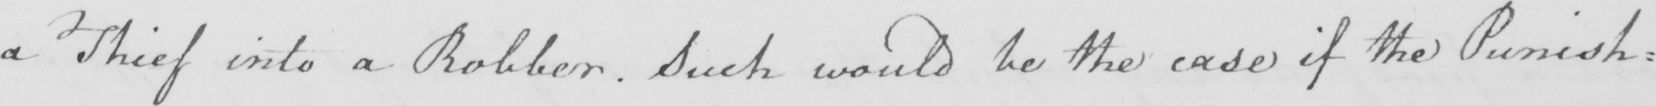What does this handwritten line say? a Thief into a Robber . Such would be the case if the Punish= 